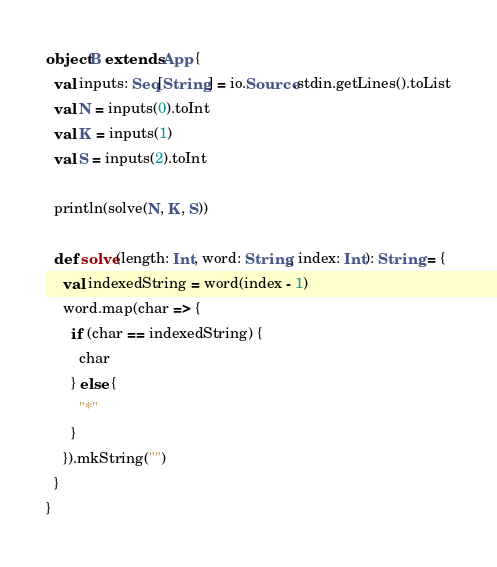<code> <loc_0><loc_0><loc_500><loc_500><_Scala_>object B extends App {
  val inputs: Seq[String] = io.Source.stdin.getLines().toList
  val N = inputs(0).toInt
  val K = inputs(1)
  val S = inputs(2).toInt

  println(solve(N, K, S))

  def solve(length: Int, word: String, index: Int): String = {
    val indexedString = word(index - 1)
    word.map(char => {
      if (char == indexedString) {
        char
      } else {
        "*"
      }
    }).mkString("")
  }
}
</code> 